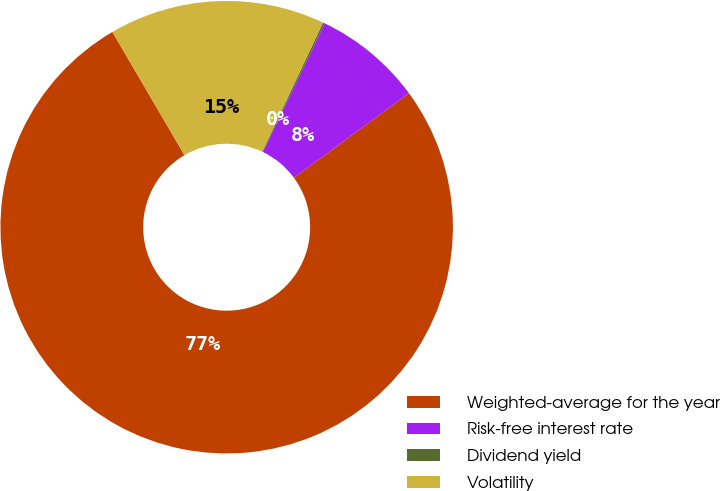Convert chart. <chart><loc_0><loc_0><loc_500><loc_500><pie_chart><fcel>Weighted-average for the year<fcel>Risk-free interest rate<fcel>Dividend yield<fcel>Volatility<nl><fcel>76.65%<fcel>7.78%<fcel>0.13%<fcel>15.43%<nl></chart> 